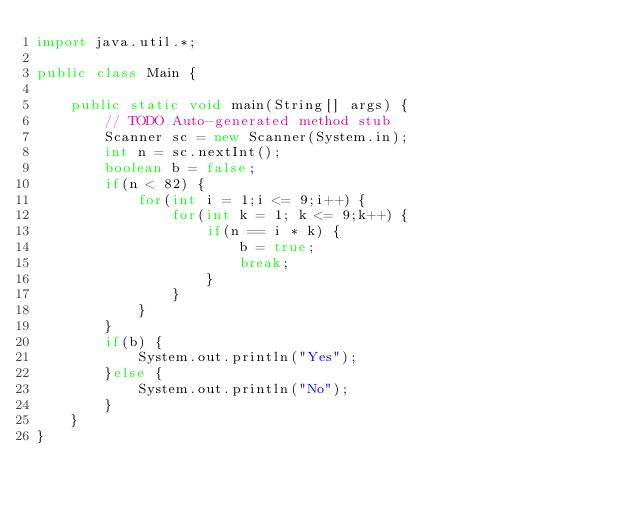<code> <loc_0><loc_0><loc_500><loc_500><_Java_>import java.util.*;

public class Main {

	public static void main(String[] args) {
		// TODO Auto-generated method stub
		Scanner sc = new Scanner(System.in);
		int n = sc.nextInt();
		boolean b = false;
		if(n < 82) {
			for(int i = 1;i <= 9;i++) {
				for(int k = 1; k <= 9;k++) {
					if(n == i * k) {
						b = true;
						break;
					}
				}
			}
		}
		if(b) {
			System.out.println("Yes");
		}else {
			System.out.println("No");
		}
	}
}
</code> 